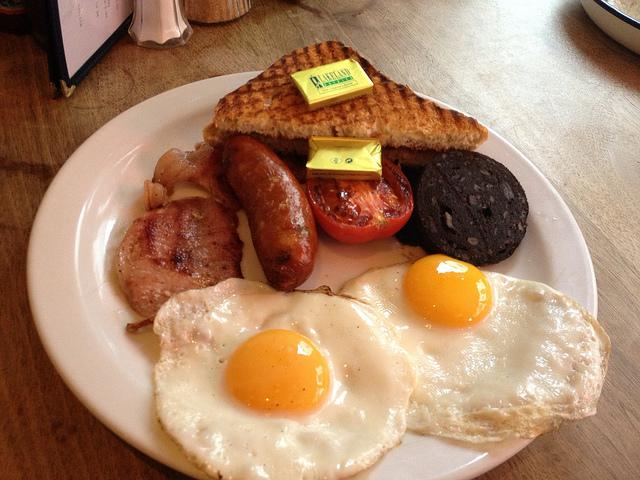How many eggs are served in this breakfast overeasy? Please explain your reasoning. two. There are two eggs served at the bottom of the breakfast. 